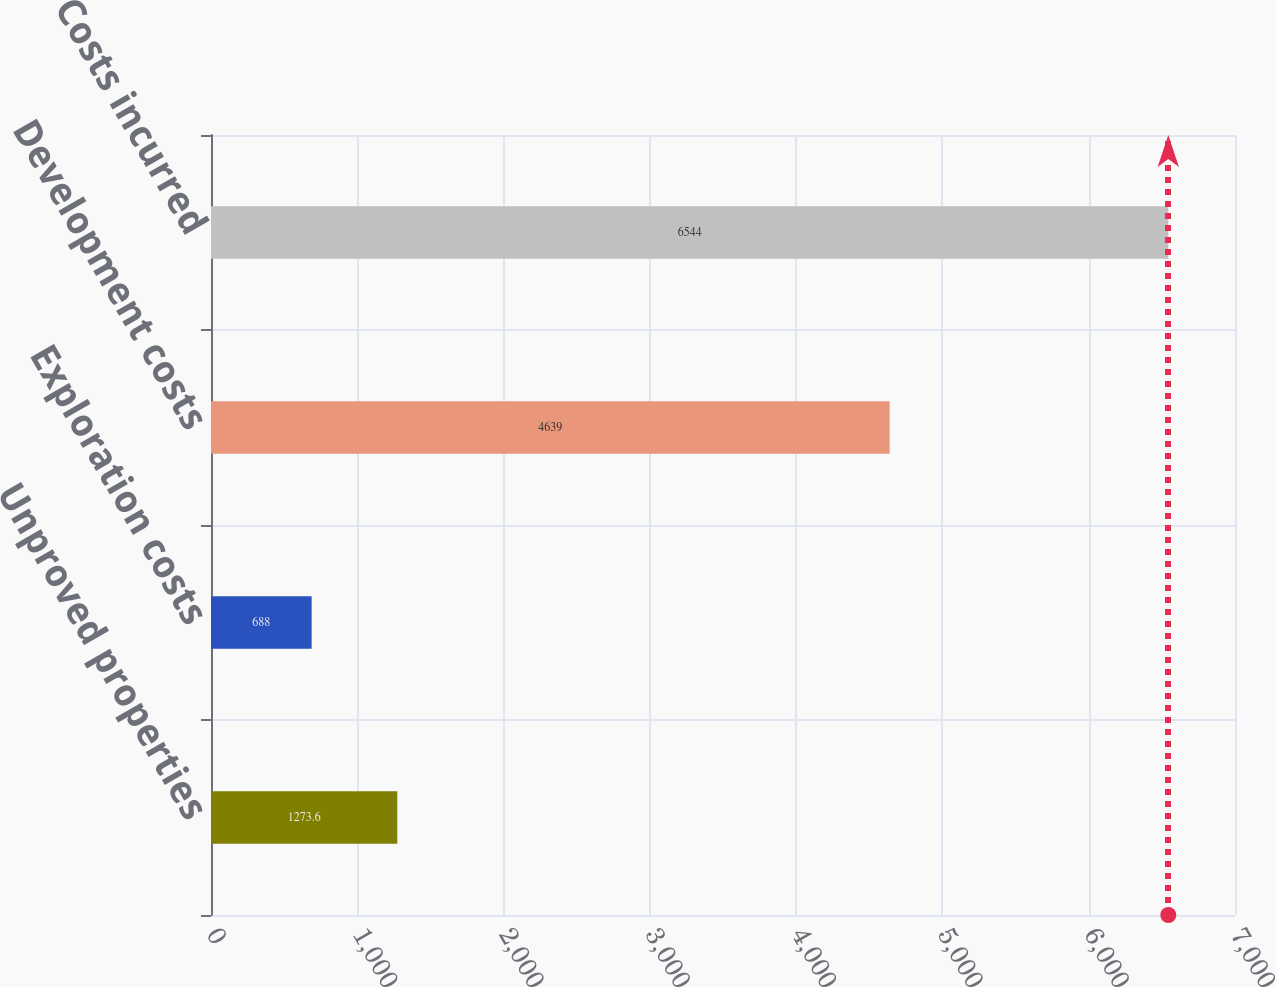Convert chart. <chart><loc_0><loc_0><loc_500><loc_500><bar_chart><fcel>Unproved properties<fcel>Exploration costs<fcel>Development costs<fcel>Costs incurred<nl><fcel>1273.6<fcel>688<fcel>4639<fcel>6544<nl></chart> 